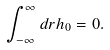<formula> <loc_0><loc_0><loc_500><loc_500>\int _ { - \infty } ^ { \infty } d r h _ { 0 } = 0 .</formula> 